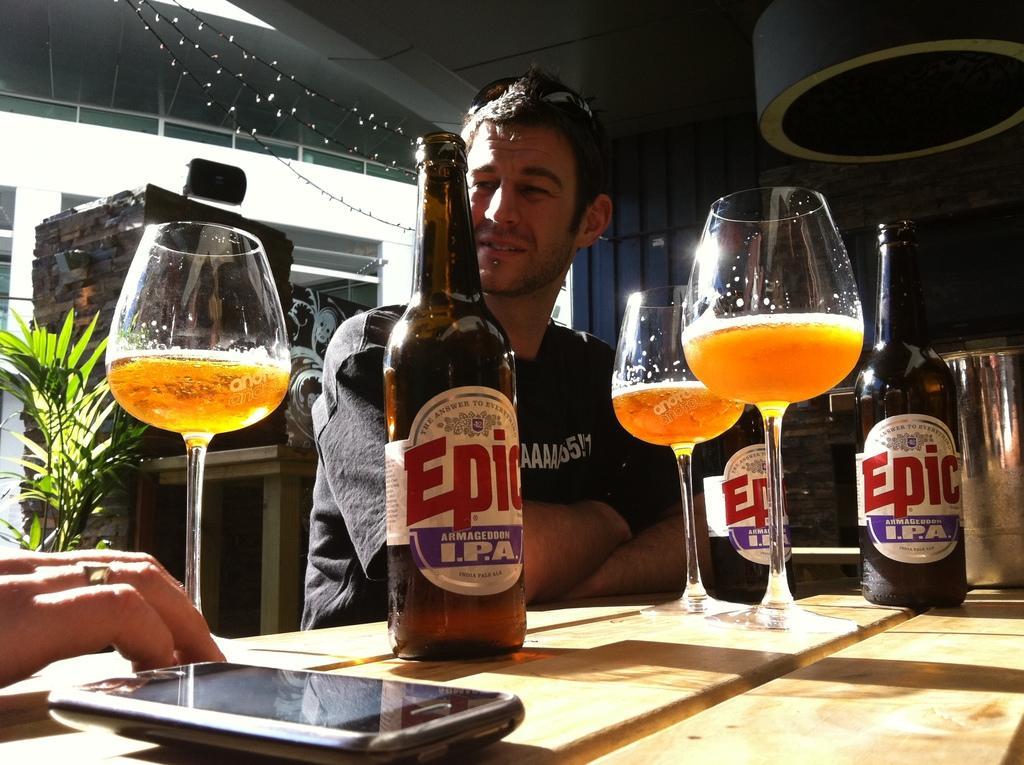Please provide a concise description of this image. In foreground of the image we can see table, cell phone and hand of a person. In the middle of the image we can see three glasses, three bottles and a person. On the top of the image we can see roof which have some lighting. 